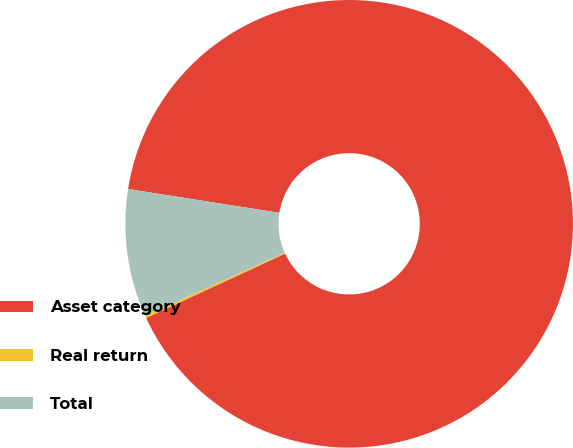<chart> <loc_0><loc_0><loc_500><loc_500><pie_chart><fcel>Asset category<fcel>Real return<fcel>Total<nl><fcel>90.6%<fcel>0.18%<fcel>9.22%<nl></chart> 